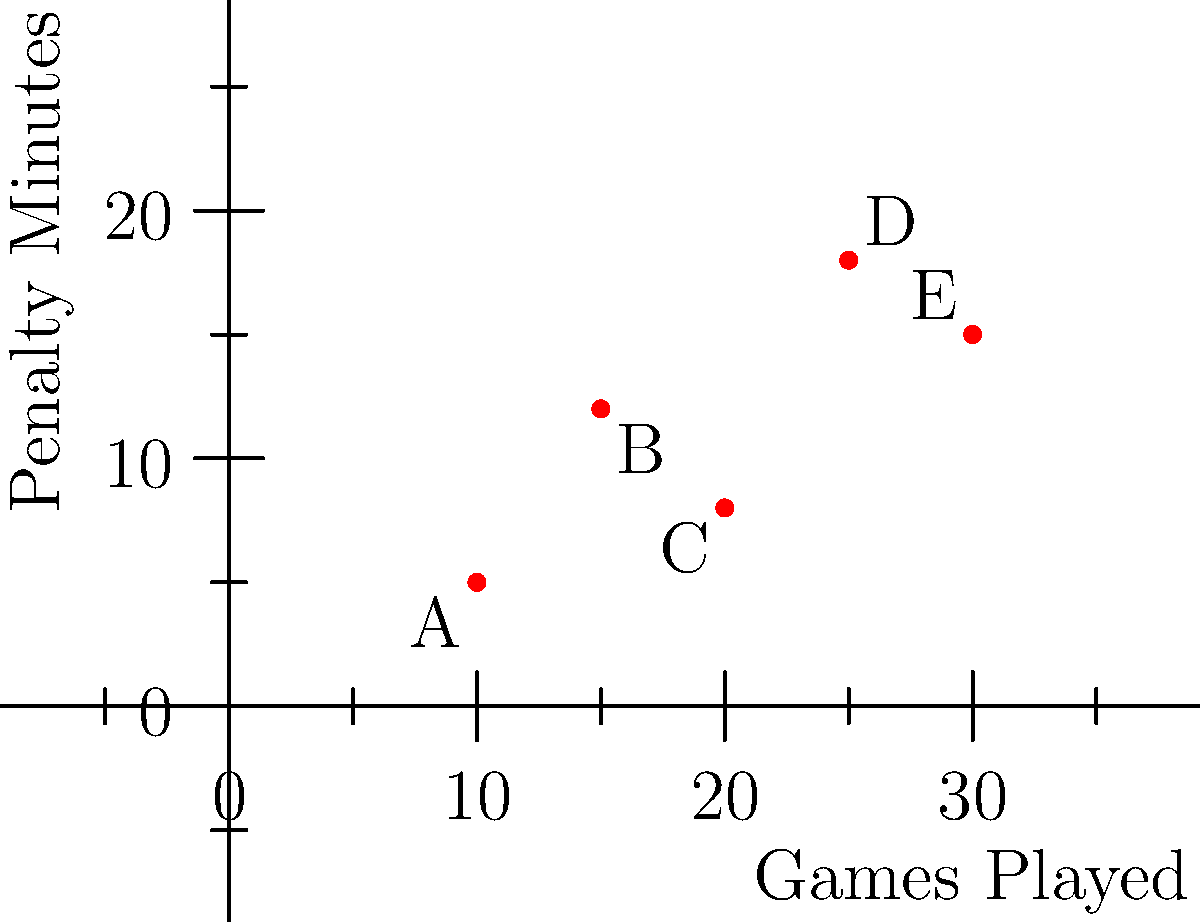Your grandson's ice hockey coach has shared a scatter plot showing the relationship between games played and penalty minutes for five players on the team. Which player seems to be the most disciplined based on their penalty minutes relative to the number of games they've played? To determine which player is the most disciplined, we need to consider the ratio of penalty minutes to games played. A lower ratio indicates better discipline. Let's calculate this for each player:

1. Player A: $\frac{5 \text{ minutes}}{10 \text{ games}} = 0.5 \text{ minutes/game}$
2. Player B: $\frac{12 \text{ minutes}}{15 \text{ games}} = 0.8 \text{ minutes/game}$
3. Player C: $\frac{8 \text{ minutes}}{20 \text{ games}} = 0.4 \text{ minutes/game}$
4. Player D: $\frac{18 \text{ minutes}}{25 \text{ games}} = 0.72 \text{ minutes/game}$
5. Player E: $\frac{15 \text{ minutes}}{30 \text{ games}} = 0.5 \text{ minutes/game}$

Player C has the lowest ratio of penalty minutes per game at 0.4, indicating they are the most disciplined player among the five.
Answer: Player C 